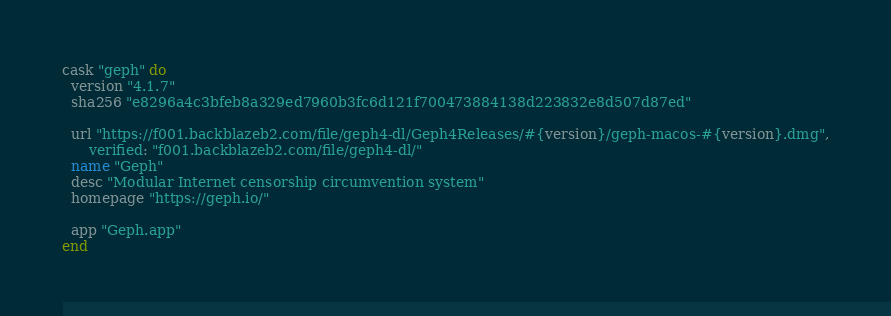<code> <loc_0><loc_0><loc_500><loc_500><_Ruby_>cask "geph" do
  version "4.1.7"
  sha256 "e8296a4c3bfeb8a329ed7960b3fc6d121f700473884138d223832e8d507d87ed"

  url "https://f001.backblazeb2.com/file/geph4-dl/Geph4Releases/#{version}/geph-macos-#{version}.dmg",
      verified: "f001.backblazeb2.com/file/geph4-dl/"
  name "Geph"
  desc "Modular Internet censorship circumvention system"
  homepage "https://geph.io/"

  app "Geph.app"
end
</code> 